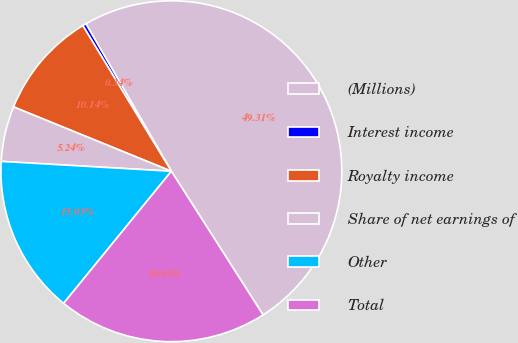<chart> <loc_0><loc_0><loc_500><loc_500><pie_chart><fcel>(Millions)<fcel>Interest income<fcel>Royalty income<fcel>Share of net earnings of<fcel>Other<fcel>Total<nl><fcel>49.31%<fcel>0.34%<fcel>10.14%<fcel>5.24%<fcel>15.03%<fcel>19.93%<nl></chart> 